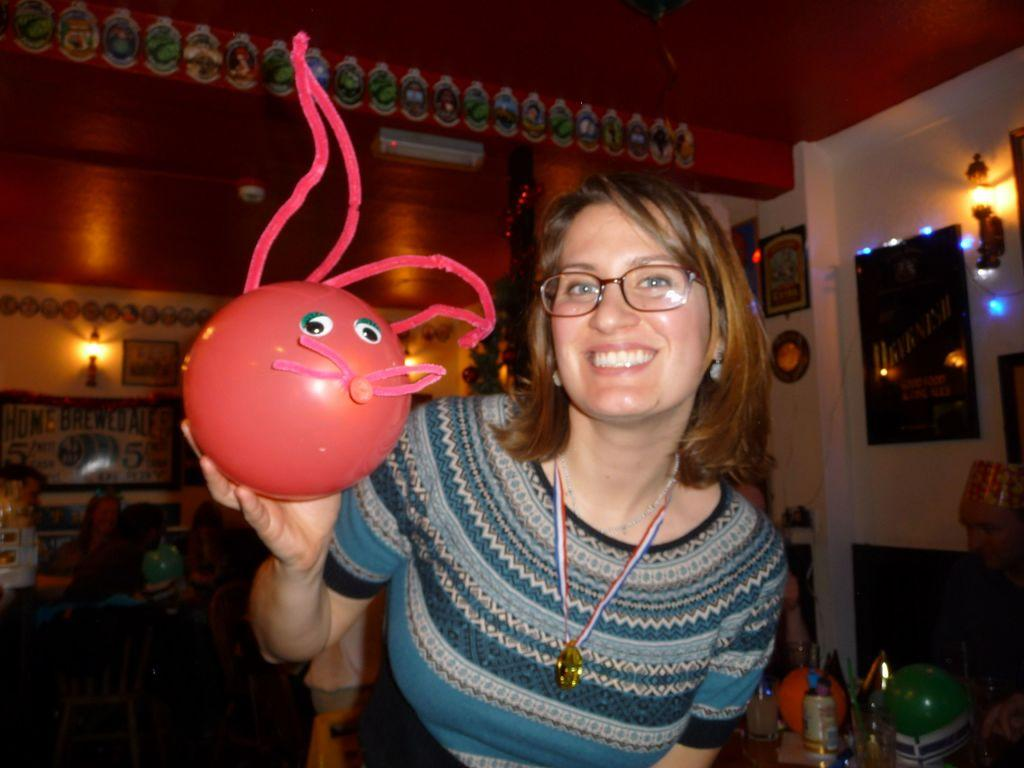Who is present in the image? There is a woman in the image. What is the woman holding in the image? The woman is holding an item. What can be seen behind the woman in the image? There are items visible behind the woman. Can you describe the wall in the image? There is a wall with decorative items in the image. What type of knee injury can be seen on the woman in the image? There is no knee injury visible on the woman in the image. 